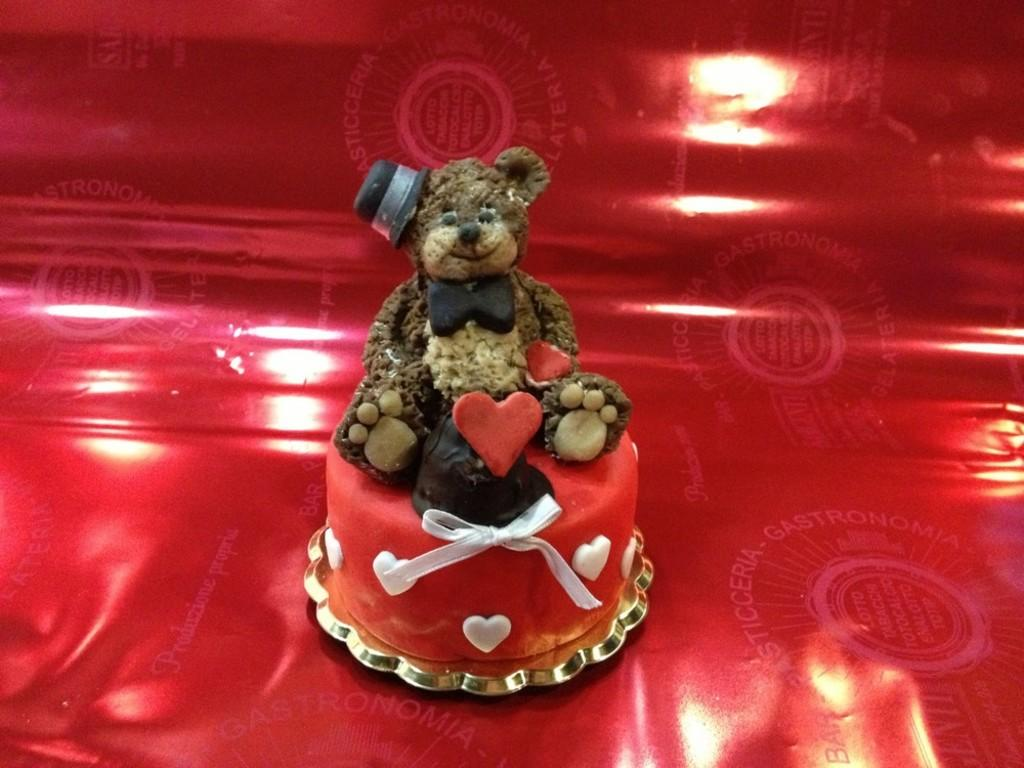What is on top of the cake in the image? There is a teddy bear on the cake in the image. How does the teddy bear contribute to the learning process in the image? The image does not depict a learning process, and the teddy bear is not related to any learning activity. 